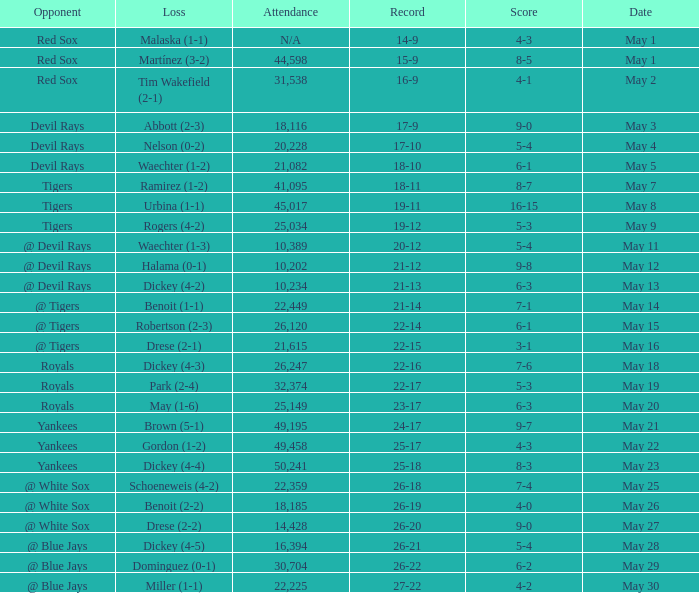What is the score of the game attended by 25,034? 5-3. 